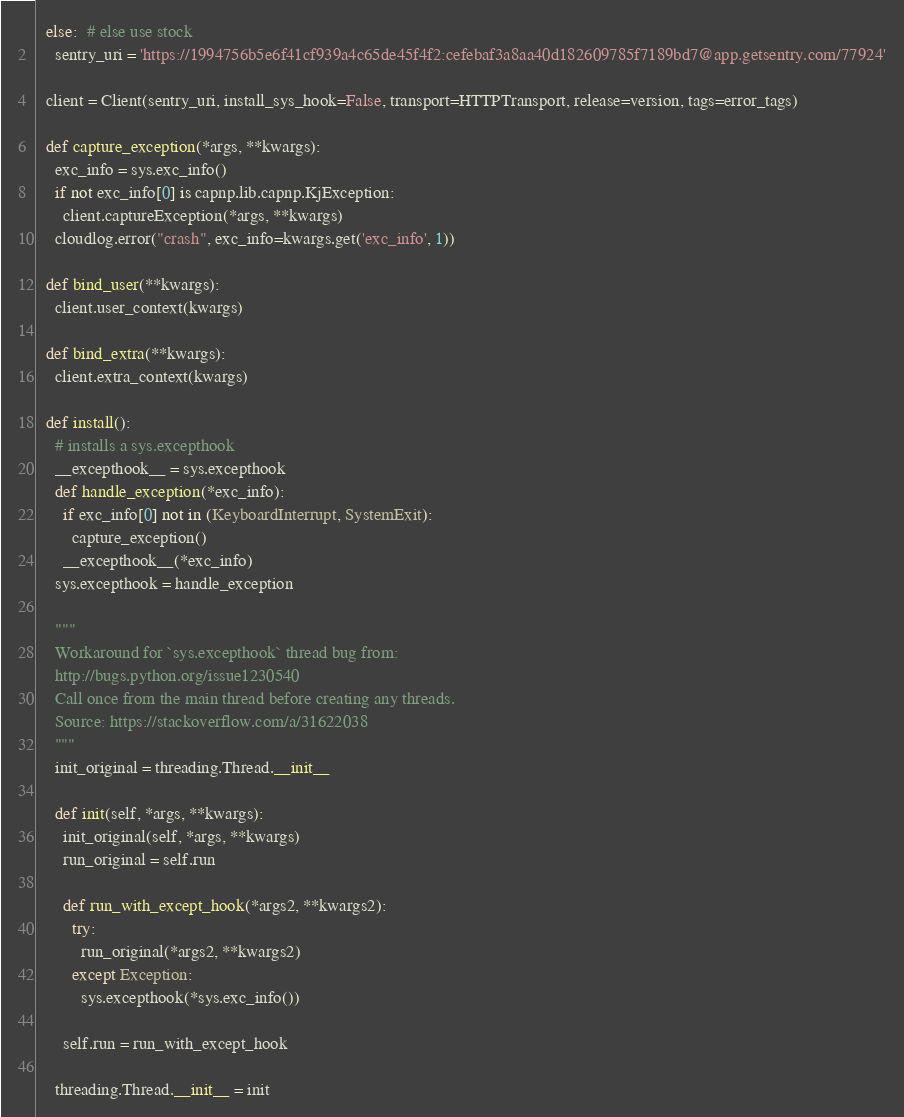Convert code to text. <code><loc_0><loc_0><loc_500><loc_500><_Python_>  else:  # else use stock
    sentry_uri = 'https://1994756b5e6f41cf939a4c65de45f4f2:cefebaf3a8aa40d182609785f7189bd7@app.getsentry.com/77924'

  client = Client(sentry_uri, install_sys_hook=False, transport=HTTPTransport, release=version, tags=error_tags)

  def capture_exception(*args, **kwargs):
    exc_info = sys.exc_info()
    if not exc_info[0] is capnp.lib.capnp.KjException:
      client.captureException(*args, **kwargs)
    cloudlog.error("crash", exc_info=kwargs.get('exc_info', 1))

  def bind_user(**kwargs):
    client.user_context(kwargs)

  def bind_extra(**kwargs):
    client.extra_context(kwargs)

  def install():
    # installs a sys.excepthook
    __excepthook__ = sys.excepthook
    def handle_exception(*exc_info):
      if exc_info[0] not in (KeyboardInterrupt, SystemExit):
        capture_exception()
      __excepthook__(*exc_info)
    sys.excepthook = handle_exception

    """
    Workaround for `sys.excepthook` thread bug from:
    http://bugs.python.org/issue1230540
    Call once from the main thread before creating any threads.
    Source: https://stackoverflow.com/a/31622038
    """
    init_original = threading.Thread.__init__

    def init(self, *args, **kwargs):
      init_original(self, *args, **kwargs)
      run_original = self.run

      def run_with_except_hook(*args2, **kwargs2):
        try:
          run_original(*args2, **kwargs2)
        except Exception:
          sys.excepthook(*sys.exc_info())

      self.run = run_with_except_hook

    threading.Thread.__init__ = init
</code> 